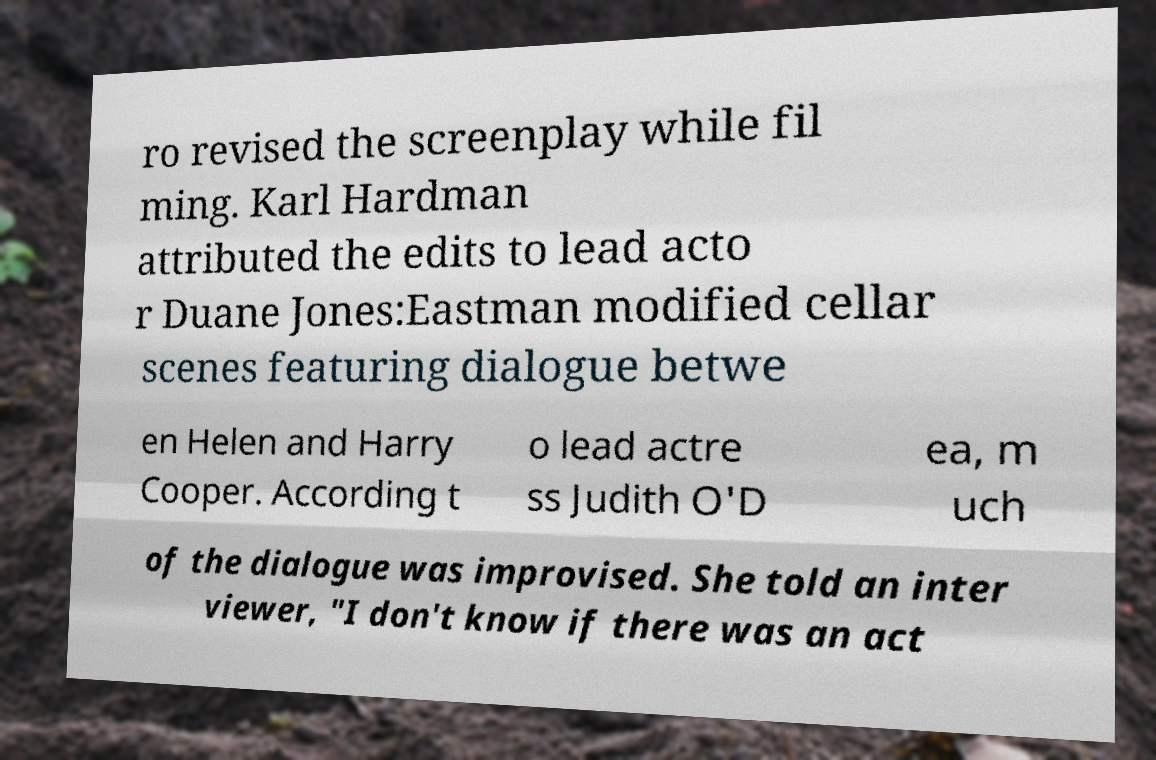For documentation purposes, I need the text within this image transcribed. Could you provide that? ro revised the screenplay while fil ming. Karl Hardman attributed the edits to lead acto r Duane Jones:Eastman modified cellar scenes featuring dialogue betwe en Helen and Harry Cooper. According t o lead actre ss Judith O'D ea, m uch of the dialogue was improvised. She told an inter viewer, "I don't know if there was an act 